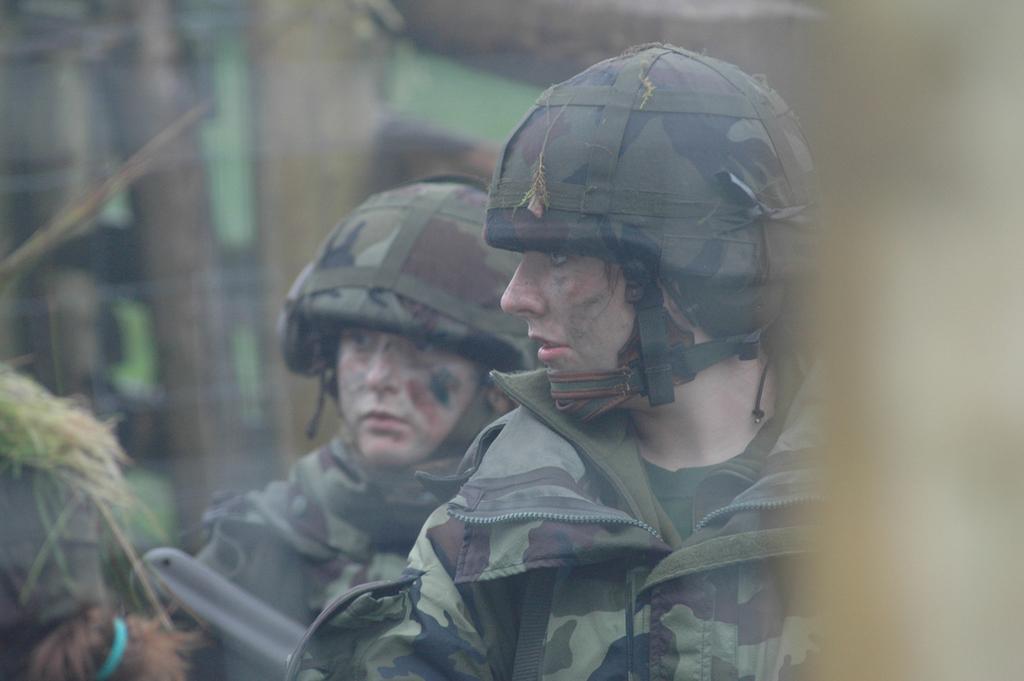Could you give a brief overview of what you see in this image? In this image we can see persons standing. 